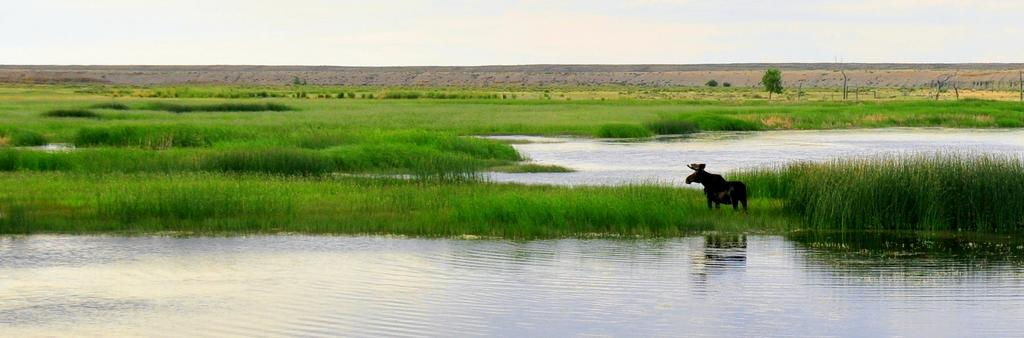What is unusual about the grass in the image? The grass is in the water. What can be seen in the grass? There is an animal in the grass. What is visible behind the grass? There are trees and plants behind the grass. What is visible at the top of the image? The sky is visible at the top of the image. What type of ice can be seen melting in the image? There is no ice present in the image; it features grass in the water with an animal and trees in the background. How high is the kite flying in the image? There is no kite present in the image; it only shows grass in the water, an animal, trees, and the sky. 